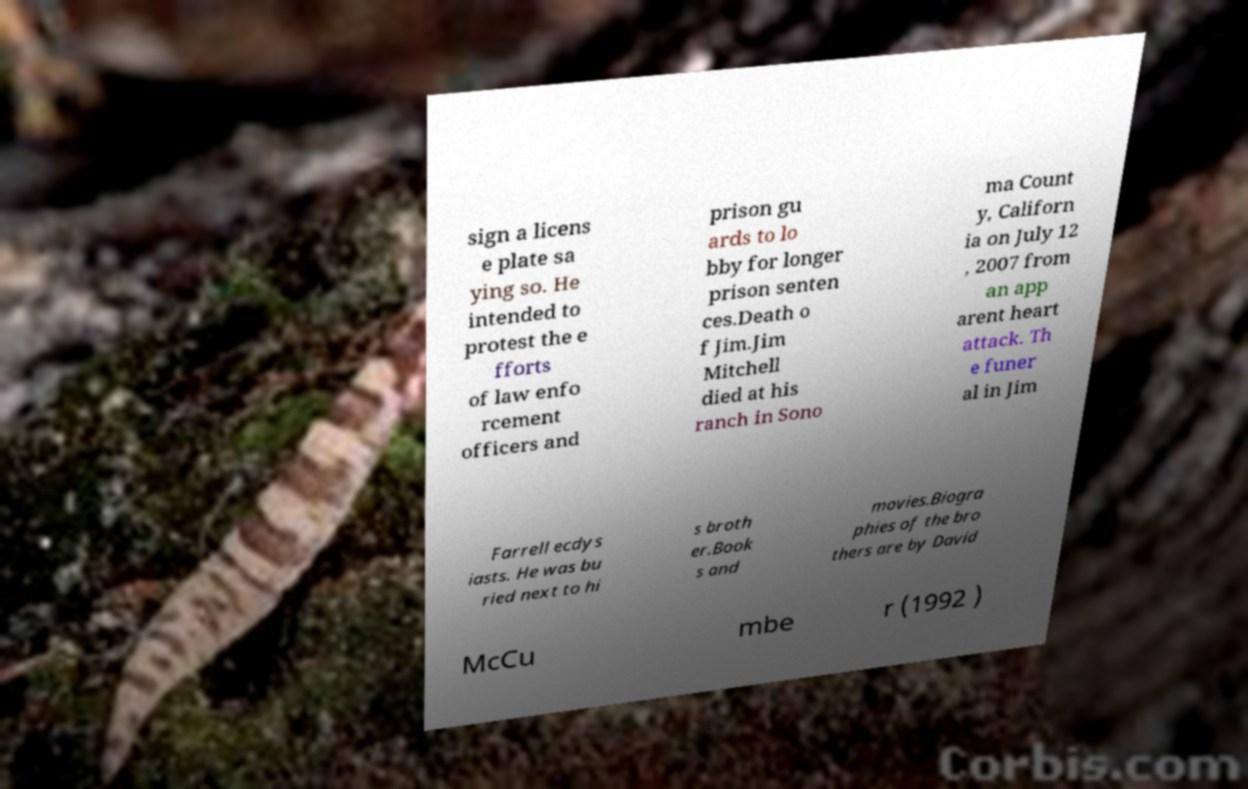Can you accurately transcribe the text from the provided image for me? sign a licens e plate sa ying so. He intended to protest the e fforts of law enfo rcement officers and prison gu ards to lo bby for longer prison senten ces.Death o f Jim.Jim Mitchell died at his ranch in Sono ma Count y, Californ ia on July 12 , 2007 from an app arent heart attack. Th e funer al in Jim Farrell ecdys iasts. He was bu ried next to hi s broth er.Book s and movies.Biogra phies of the bro thers are by David McCu mbe r (1992 ) 